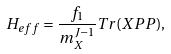Convert formula to latex. <formula><loc_0><loc_0><loc_500><loc_500>H _ { e f f } = \frac { f _ { 1 } } { m _ { X } ^ { J - 1 } } T r ( X P P ) ,</formula> 